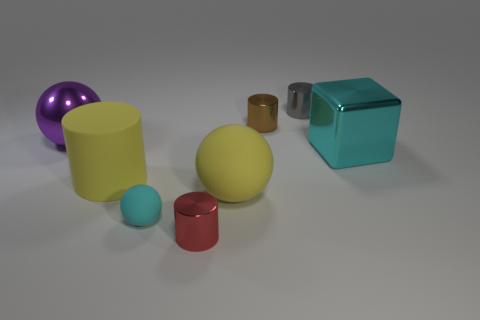Subtract all tiny red metallic cylinders. How many cylinders are left? 3 Add 1 tiny yellow rubber objects. How many objects exist? 9 Subtract all spheres. How many objects are left? 5 Subtract 1 blocks. How many blocks are left? 0 Add 5 cyan metal blocks. How many cyan metal blocks are left? 6 Add 6 small yellow objects. How many small yellow objects exist? 6 Subtract all yellow spheres. How many spheres are left? 2 Subtract 0 gray spheres. How many objects are left? 8 Subtract all purple spheres. Subtract all brown cylinders. How many spheres are left? 2 Subtract all cyan spheres. How many blue cylinders are left? 0 